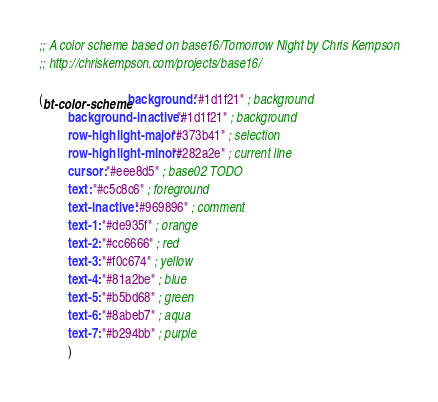Convert code to text. <code><loc_0><loc_0><loc_500><loc_500><_Scheme_>;; A color scheme based on base16/Tomorrow Night by Chris Kempson
;; http://chriskempson.com/projects/base16/

(bt-color-scheme background: "#1d1f21" ; background
		 background-inactive: "#1d1f21" ; background
		 row-highlight-major: "#373b41" ; selection
		 row-highlight-minor: "#282a2e" ; current line
		 cursor: "#eee8d5" ; base02 TODO
		 text: "#c5c8c6" ; foreground
		 text-inactive: "#969896" ; comment
		 text-1: "#de935f" ; orange
		 text-2: "#cc6666" ; red
		 text-3: "#f0c674" ; yellow
		 text-4: "#81a2be" ; blue
		 text-5: "#b5bd68" ; green
		 text-6: "#8abeb7" ; aqua
		 text-7: "#b294bb" ; purple
		 )
</code> 